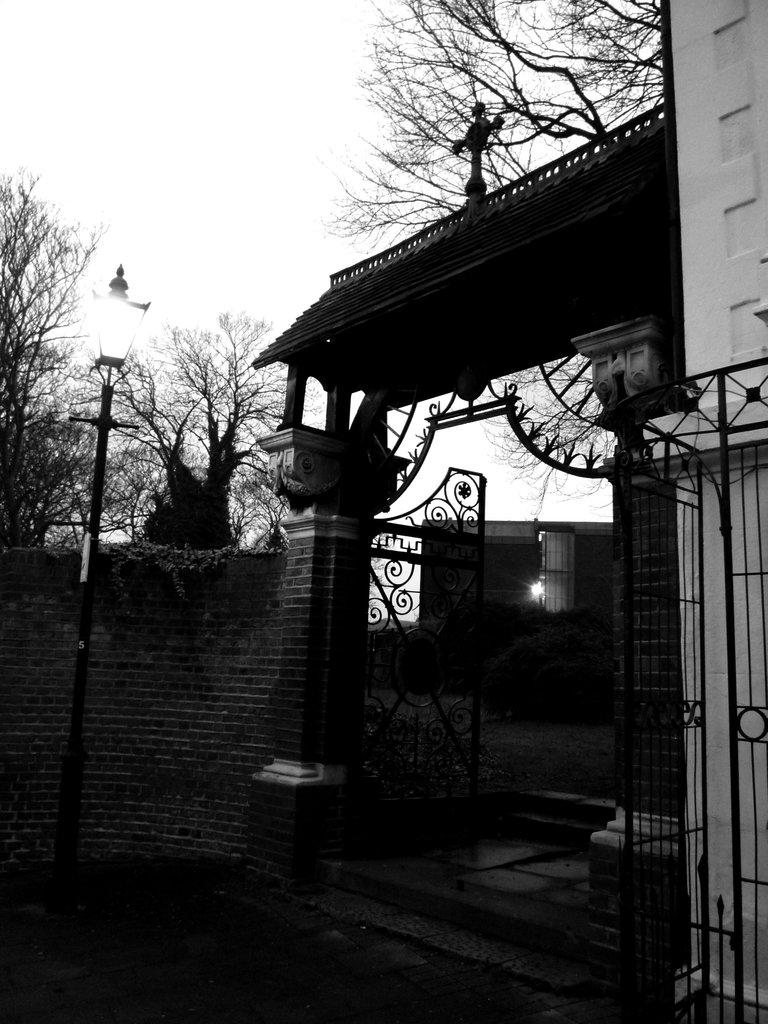What is the color scheme of the image? The image is black and white. What can be seen on the path in the image? There is a street light on the path in the image. What structure is present in the image? There is a gate in the image. What type of vegetation is visible in the image? There are plants visible in the image. What is visible in the background of the image? A light is visible in the background of the image. Can you tell me what type of doctor is standing near the gate in the image? There is no doctor present in the image; it features a street light, gate, plants, and a light in the background. What type of bat is flying near the street light in the image? There are no bats present in the image; it is a black and white image with a street light, gate, plants, and a light in the background. 